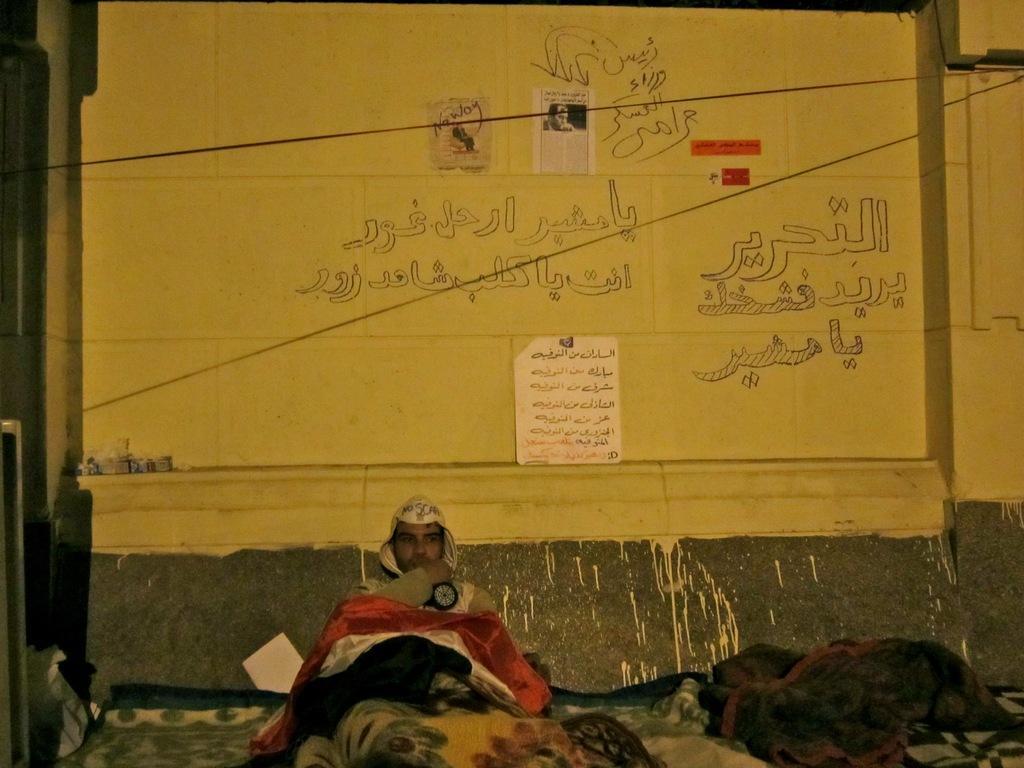Please provide a concise description of this image. There is a man sitting on the bed. Here we can see clothes. In the background there is a wall and posters. 